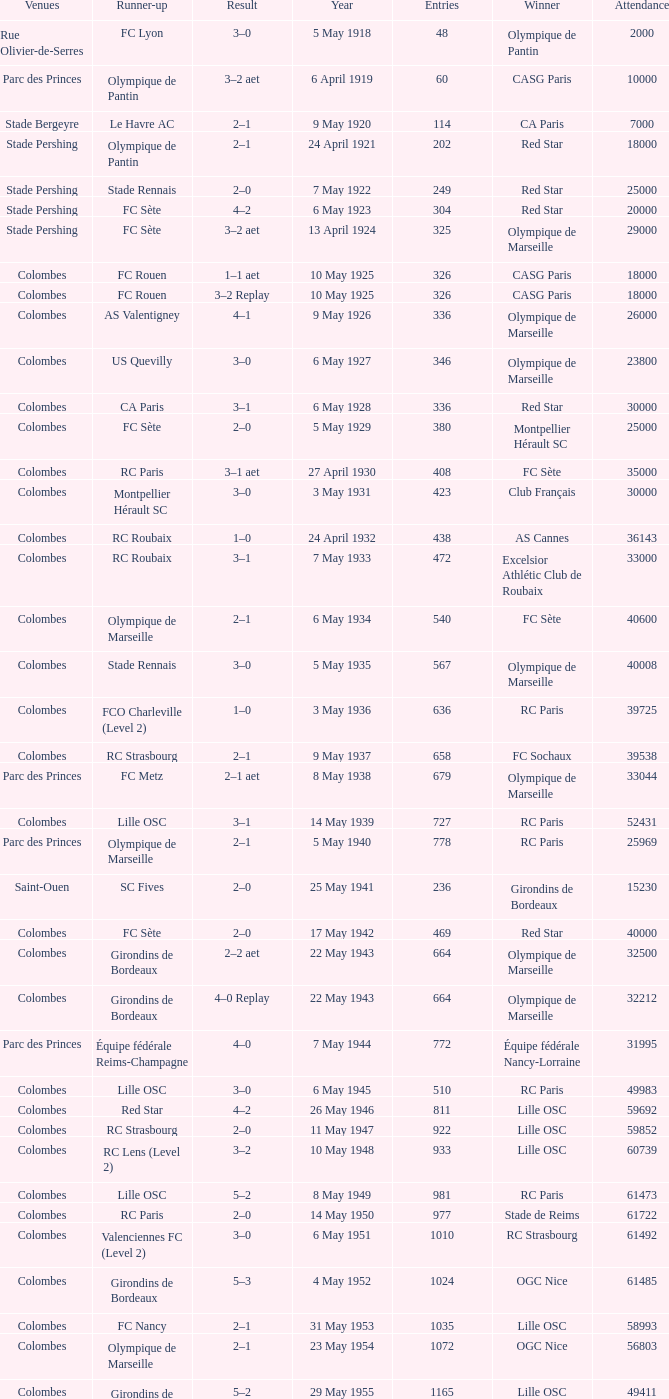What is the fewest recorded entrants against paris saint-germain? 6394.0. 